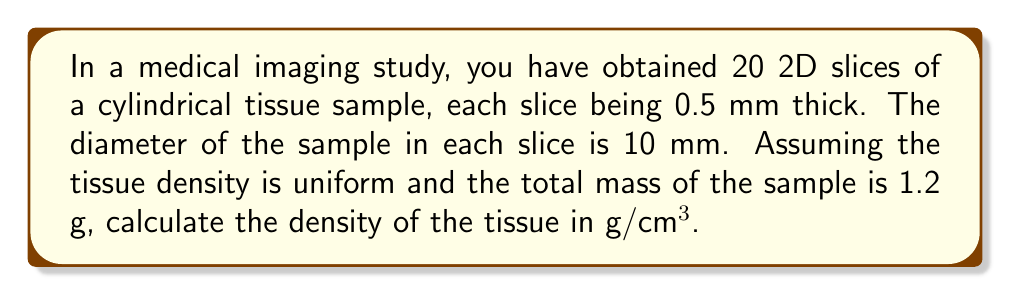What is the answer to this math problem? Let's approach this step-by-step:

1) First, we need to calculate the volume of the tissue sample:

   a) The height of the cylinder is the number of slices multiplied by the thickness of each slice:
      $h = 20 \times 0.5\text{ mm} = 10\text{ mm} = 1\text{ cm}$

   b) The radius of the cylinder is half the diameter:
      $r = 10\text{ mm} \div 2 = 5\text{ mm} = 0.5\text{ cm}$

   c) The volume of a cylinder is given by $V = \pi r^2 h$:
      $V = \pi \times (0.5\text{ cm})^2 \times 1\text{ cm} = 0.25\pi\text{ cm}^3$

2) We're given that the total mass of the sample is 1.2 g.

3) The density is defined as mass divided by volume:

   $$\rho = \frac{m}{V}$$

4) Substituting our values:

   $$\rho = \frac{1.2\text{ g}}{0.25\pi\text{ cm}^3} = \frac{4.8}{\pi}\text{ g/cm}^3$$

5) Calculating this:

   $$\rho \approx 1.53\text{ g/cm}^3$$
Answer: $1.53\text{ g/cm}^3$ 